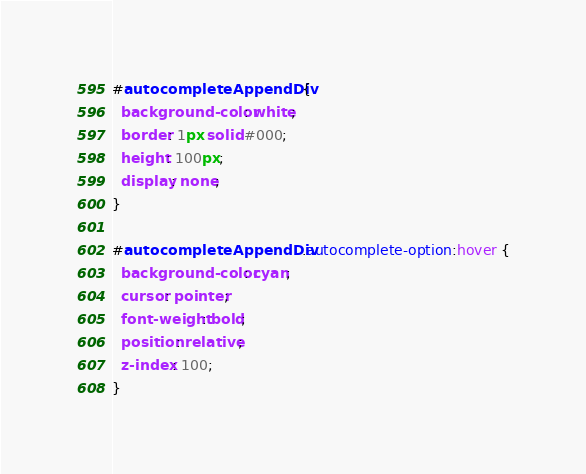Convert code to text. <code><loc_0><loc_0><loc_500><loc_500><_CSS_>#autocompleteAppendDiv {
  background-color: white;
  border: 1px solid #000;
  height: 100px;
  display: none;
}

#autocompleteAppendDiv .autocomplete-option:hover {
  background-color: cyan;
  cursor: pointer;
  font-weight: bold;
  position: relative;
  z-index: 100;
}
</code> 